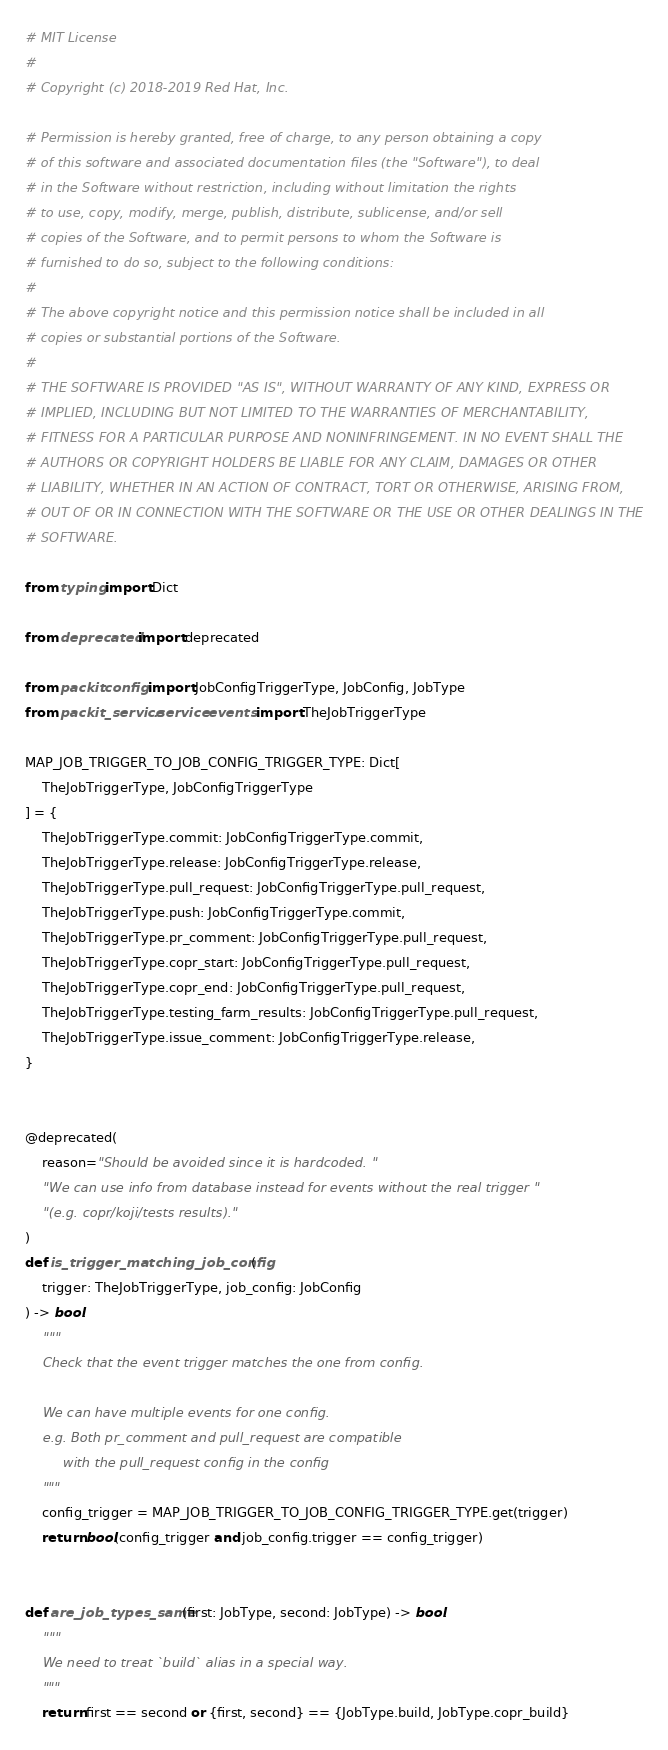<code> <loc_0><loc_0><loc_500><loc_500><_Python_># MIT License
#
# Copyright (c) 2018-2019 Red Hat, Inc.

# Permission is hereby granted, free of charge, to any person obtaining a copy
# of this software and associated documentation files (the "Software"), to deal
# in the Software without restriction, including without limitation the rights
# to use, copy, modify, merge, publish, distribute, sublicense, and/or sell
# copies of the Software, and to permit persons to whom the Software is
# furnished to do so, subject to the following conditions:
#
# The above copyright notice and this permission notice shall be included in all
# copies or substantial portions of the Software.
#
# THE SOFTWARE IS PROVIDED "AS IS", WITHOUT WARRANTY OF ANY KIND, EXPRESS OR
# IMPLIED, INCLUDING BUT NOT LIMITED TO THE WARRANTIES OF MERCHANTABILITY,
# FITNESS FOR A PARTICULAR PURPOSE AND NONINFRINGEMENT. IN NO EVENT SHALL THE
# AUTHORS OR COPYRIGHT HOLDERS BE LIABLE FOR ANY CLAIM, DAMAGES OR OTHER
# LIABILITY, WHETHER IN AN ACTION OF CONTRACT, TORT OR OTHERWISE, ARISING FROM,
# OUT OF OR IN CONNECTION WITH THE SOFTWARE OR THE USE OR OTHER DEALINGS IN THE
# SOFTWARE.

from typing import Dict

from deprecated import deprecated

from packit.config import JobConfigTriggerType, JobConfig, JobType
from packit_service.service.events import TheJobTriggerType

MAP_JOB_TRIGGER_TO_JOB_CONFIG_TRIGGER_TYPE: Dict[
    TheJobTriggerType, JobConfigTriggerType
] = {
    TheJobTriggerType.commit: JobConfigTriggerType.commit,
    TheJobTriggerType.release: JobConfigTriggerType.release,
    TheJobTriggerType.pull_request: JobConfigTriggerType.pull_request,
    TheJobTriggerType.push: JobConfigTriggerType.commit,
    TheJobTriggerType.pr_comment: JobConfigTriggerType.pull_request,
    TheJobTriggerType.copr_start: JobConfigTriggerType.pull_request,
    TheJobTriggerType.copr_end: JobConfigTriggerType.pull_request,
    TheJobTriggerType.testing_farm_results: JobConfigTriggerType.pull_request,
    TheJobTriggerType.issue_comment: JobConfigTriggerType.release,
}


@deprecated(
    reason="Should be avoided since it is hardcoded. "
    "We can use info from database instead for events without the real trigger "
    "(e.g. copr/koji/tests results)."
)
def is_trigger_matching_job_config(
    trigger: TheJobTriggerType, job_config: JobConfig
) -> bool:
    """
    Check that the event trigger matches the one from config.

    We can have multiple events for one config.
    e.g. Both pr_comment and pull_request are compatible
         with the pull_request config in the config
    """
    config_trigger = MAP_JOB_TRIGGER_TO_JOB_CONFIG_TRIGGER_TYPE.get(trigger)
    return bool(config_trigger and job_config.trigger == config_trigger)


def are_job_types_same(first: JobType, second: JobType) -> bool:
    """
    We need to treat `build` alias in a special way.
    """
    return first == second or {first, second} == {JobType.build, JobType.copr_build}
</code> 